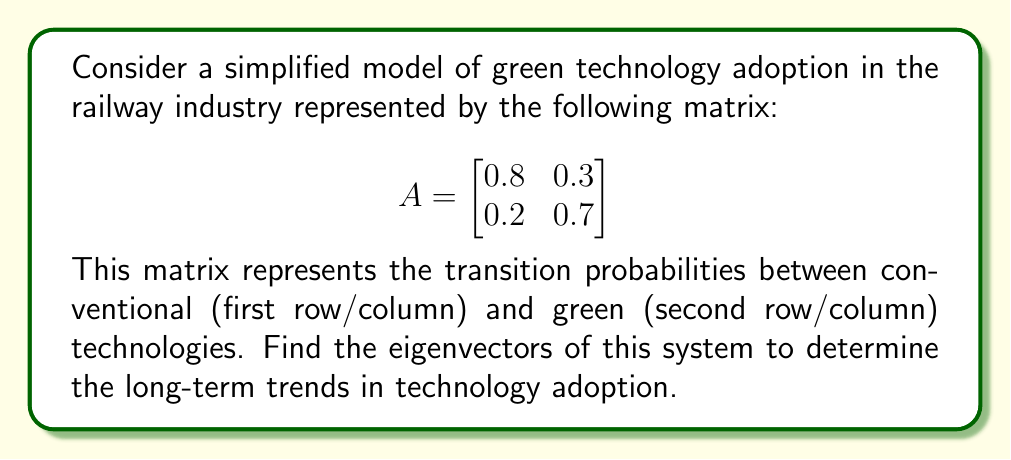Can you answer this question? To find the eigenvectors, we follow these steps:

1) First, we need to find the eigenvalues by solving the characteristic equation:
   $$\det(A - \lambda I) = 0$$

2) Expanding this:
   $$\begin{vmatrix}
   0.8 - \lambda & 0.3 \\
   0.2 & 0.7 - \lambda
   \end{vmatrix} = 0$$

3) This gives us:
   $$(0.8 - \lambda)(0.7 - \lambda) - 0.06 = 0$$
   $$\lambda^2 - 1.5\lambda + 0.5 = 0$$

4) Solving this quadratic equation:
   $$\lambda_1 = 1, \lambda_2 = 0.5$$

5) For $\lambda_1 = 1$, we solve $(A - I)\mathbf{v_1} = \mathbf{0}$:
   $$\begin{bmatrix}
   -0.2 & 0.3 \\
   0.2 & -0.3
   \end{bmatrix}\begin{bmatrix}
   v_1 \\
   v_2
   \end{bmatrix} = \begin{bmatrix}
   0 \\
   0
   \end{bmatrix}$$

6) This gives us $v_2 = \frac{2}{3}v_1$. Let $v_1 = 3$, then $v_2 = 2$.
   So, $\mathbf{v_1} = \begin{bmatrix} 3 \\ 2 \end{bmatrix}$

7) For $\lambda_2 = 0.5$, we solve $(A - 0.5I)\mathbf{v_2} = \mathbf{0}$:
   $$\begin{bmatrix}
   0.3 & 0.3 \\
   0.2 & 0.2
   \end{bmatrix}\begin{bmatrix}
   v_1 \\
   v_2
   \end{bmatrix} = \begin{bmatrix}
   0 \\
   0
   \end{bmatrix}$$

8) This gives us $v_2 = -v_1$. Let $v_1 = 1$, then $v_2 = -1$.
   So, $\mathbf{v_2} = \begin{bmatrix} 1 \\ -1 \end{bmatrix}$
Answer: $\mathbf{v_1} = \begin{bmatrix} 3 \\ 2 \end{bmatrix}$, $\mathbf{v_2} = \begin{bmatrix} 1 \\ -1 \end{bmatrix}$ 